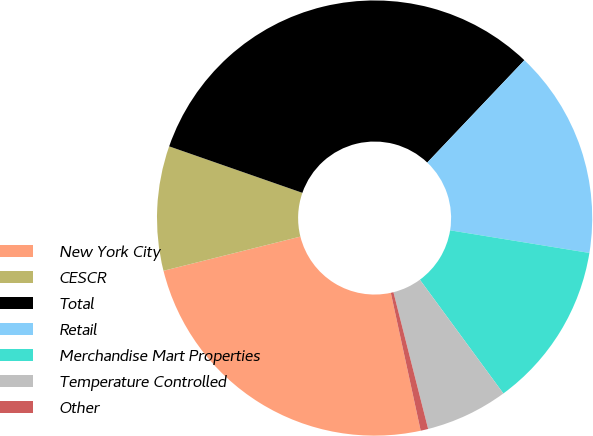Convert chart. <chart><loc_0><loc_0><loc_500><loc_500><pie_chart><fcel>New York City<fcel>CESCR<fcel>Total<fcel>Retail<fcel>Merchandise Mart Properties<fcel>Temperature Controlled<fcel>Other<nl><fcel>24.5%<fcel>9.24%<fcel>31.74%<fcel>15.48%<fcel>12.36%<fcel>6.12%<fcel>0.56%<nl></chart> 